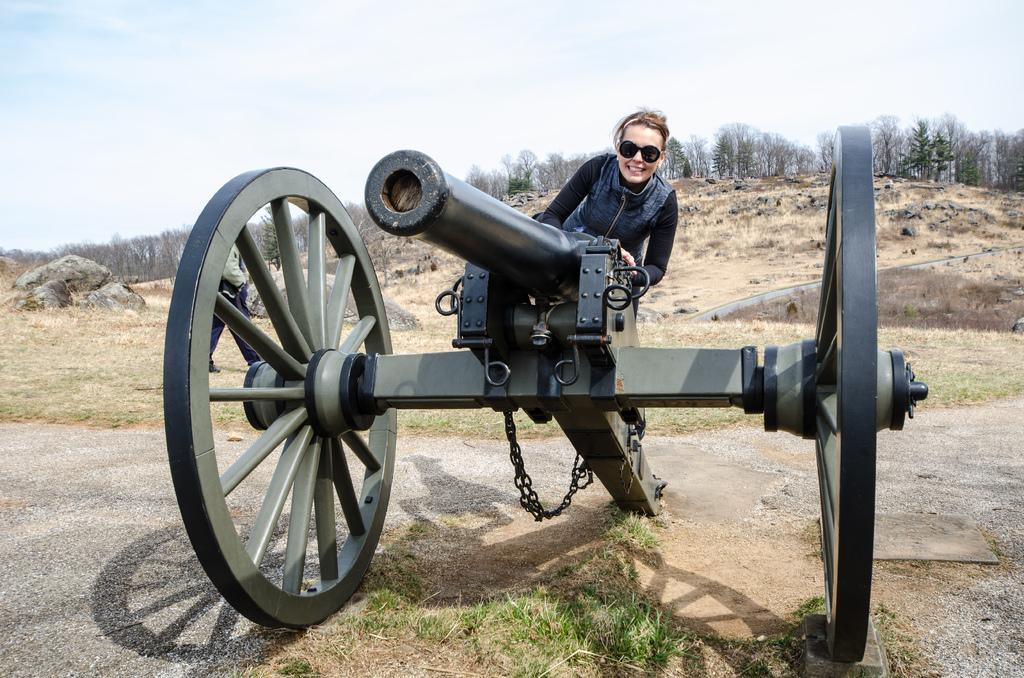What is the main object in the image? There is a canon in the image. Can you describe the person in the image? There is a person wearing a black jacket in the image. What type of vegetation is present in the image? There are trees in the image. What is the color of the trees? The trees are green in color. What is visible in the background of the image? The sky is visible in the image. What colors can be seen in the sky? The sky has white and blue colors. What is the name of the nut that is being smashed by the canon in the image? There is no nut being smashed by the canon in the image. The canon is the main object, and there is no mention of a nut or any smashing activity. 